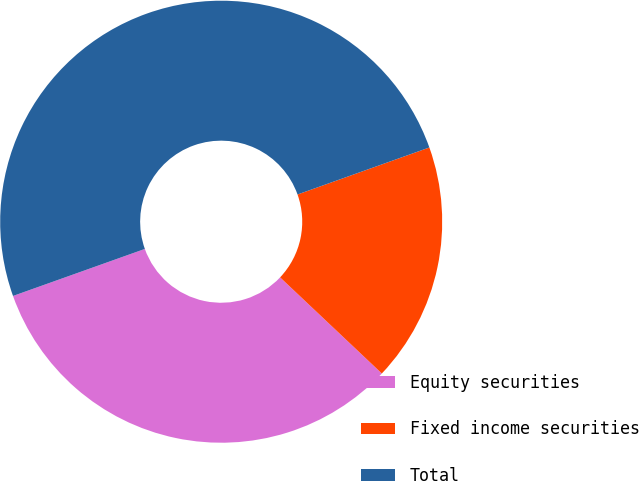Convert chart to OTSL. <chart><loc_0><loc_0><loc_500><loc_500><pie_chart><fcel>Equity securities<fcel>Fixed income securities<fcel>Total<nl><fcel>32.5%<fcel>17.5%<fcel>50.0%<nl></chart> 